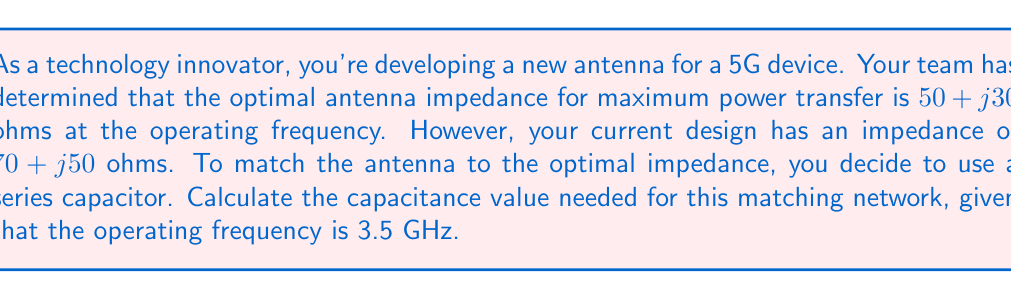Provide a solution to this math problem. To solve this problem, we'll follow these steps:

1) The goal is to transform the antenna impedance $(70 + j50)$ Ω to $(50 + j30)$ Ω using a series capacitor.

2) The difference between these impedances is what the capacitor needs to provide:
   $$(70 + j50) - (50 + j30) = 20 + j20$$

3) A series capacitor adds a negative reactive component, so we need to cancel out the $+j20$ component:
   $$Z_C = -j20$$

4) The impedance of a capacitor is given by:
   $$Z_C = \frac{1}{j\omega C}$$
   where $\omega = 2\pi f$

5) Equating these:
   $$-j20 = \frac{1}{j\omega C}$$

6) Solving for C:
   $$C = \frac{1}{20\omega} = \frac{1}{20 \cdot 2\pi f}$$

7) Substituting the frequency $f = 3.5$ GHz $= 3.5 \times 10^9$ Hz:
   $$C = \frac{1}{20 \cdot 2\pi \cdot 3.5 \times 10^9}$$

8) Calculating:
   $$C = 2.274 \times 10^{-12} \text{ F} = 2.274 \text{ pF}$$
Answer: The required capacitance for the matching network is 2.274 pF. 